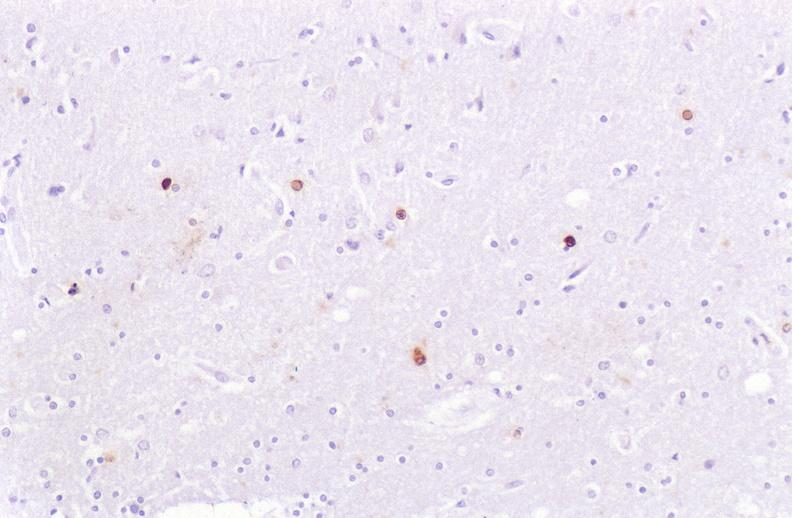does this image show brain, herpes simplex virus immunohistochemistry?
Answer the question using a single word or phrase. Yes 